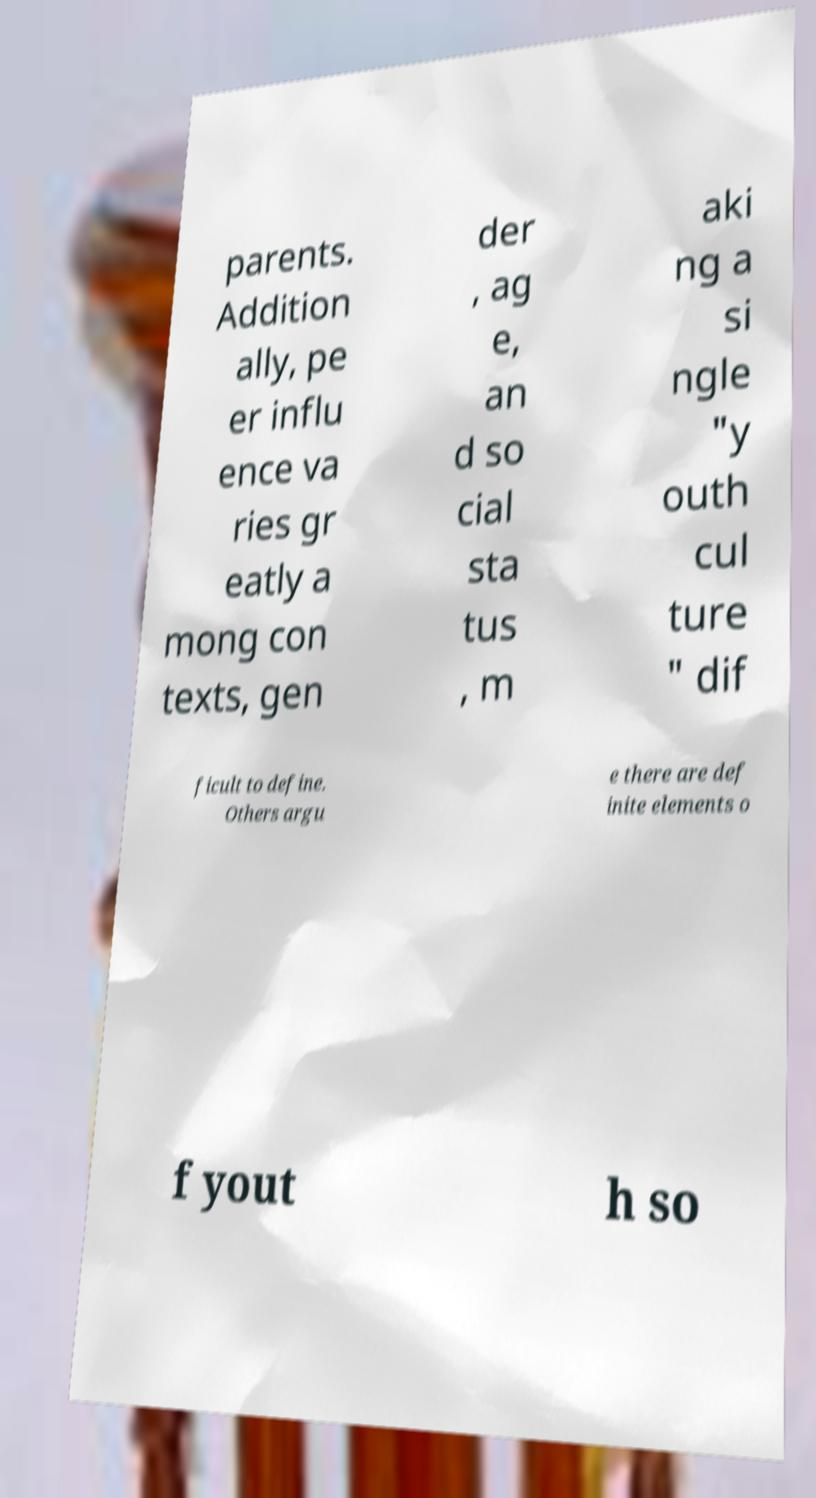Can you accurately transcribe the text from the provided image for me? parents. Addition ally, pe er influ ence va ries gr eatly a mong con texts, gen der , ag e, an d so cial sta tus , m aki ng a si ngle "y outh cul ture " dif ficult to define. Others argu e there are def inite elements o f yout h so 